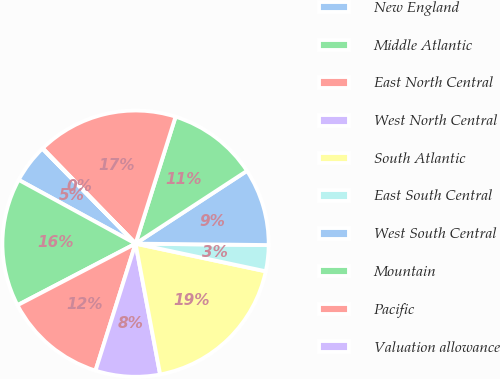Convert chart. <chart><loc_0><loc_0><loc_500><loc_500><pie_chart><fcel>New England<fcel>Middle Atlantic<fcel>East North Central<fcel>West North Central<fcel>South Atlantic<fcel>East South Central<fcel>West South Central<fcel>Mountain<fcel>Pacific<fcel>Valuation allowance<nl><fcel>4.71%<fcel>15.6%<fcel>12.49%<fcel>7.82%<fcel>18.71%<fcel>3.16%<fcel>9.38%<fcel>10.93%<fcel>17.15%<fcel>0.05%<nl></chart> 